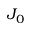Convert formula to latex. <formula><loc_0><loc_0><loc_500><loc_500>J _ { 0 }</formula> 